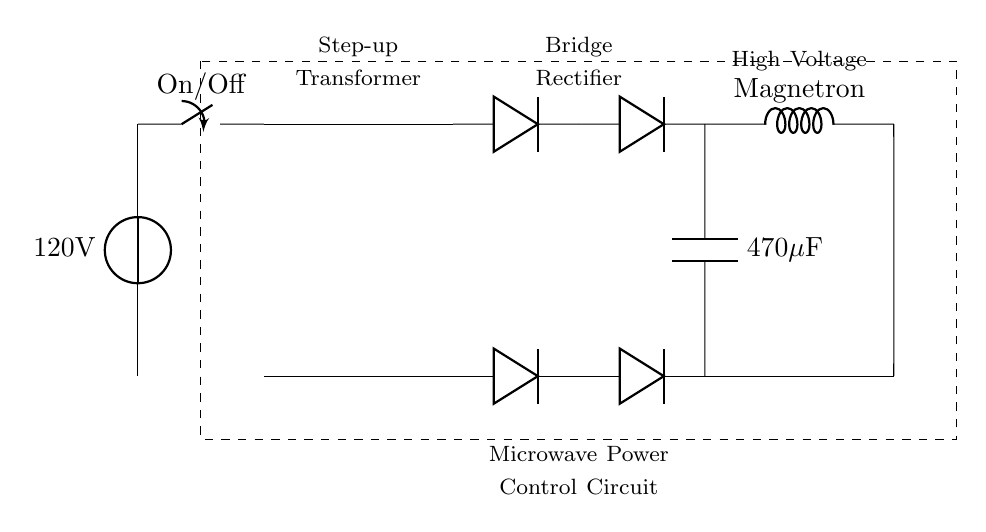What is the input voltage of this circuit? The input voltage is represented by the voltage source at the left side of the circuit diagram, labeled as 120V.
Answer: 120V What component converts high voltage AC to DC? The component that converts alternating current (AC) to direct current (DC) is the bridge rectifier, indicated by the two diodes connected in a specific arrangement.
Answer: Bridge Rectifier How many diodes are used in the bridge rectifier? The bridge rectifier consists of four diodes arranged in a manner that allows for effective conversion of AC to DC, as indicated in the circuit diagram.
Answer: Four What is the capacitance value of the capacitor in the circuit? The circuit diagram labels the capacitor as 470 microfarads, which is given directly next to the capacitor symbol.
Answer: 470 microfarads What is the purpose of the transformer in this circuit? The transformer’s purpose is to step up the voltage from the input level to a higher voltage level suitable for the microwave operation, indicated by its label in the diagram.
Answer: Step-up voltage How is the magnetron powered in this circuit? The magnetron is powered by the high voltage output from the capacitor after conversion by the rectifier, and the circuit clearly shows this connection leading to the magnetron.
Answer: High voltage from capacitor What does the dashed rectangle represent in this circuit? The dashed rectangle encompasses the entire microwave power control circuit, indicating a functional grouping of components devoted to managing and controlling microwave power.
Answer: Microwave Power Control Circuit 